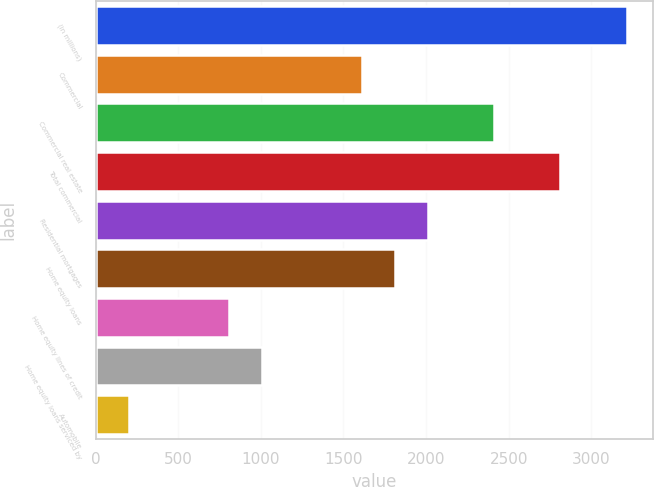Convert chart to OTSL. <chart><loc_0><loc_0><loc_500><loc_500><bar_chart><fcel>(in millions)<fcel>Commercial<fcel>Commercial real estate<fcel>Total commercial<fcel>Residential mortgages<fcel>Home equity loans<fcel>Home equity lines of credit<fcel>Home equity loans serviced by<fcel>Automobile<nl><fcel>3215.2<fcel>1609.6<fcel>2412.4<fcel>2813.8<fcel>2011<fcel>1810.3<fcel>806.8<fcel>1007.5<fcel>204.7<nl></chart> 